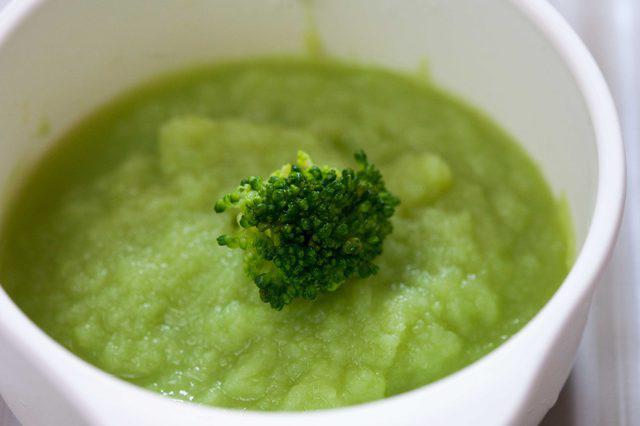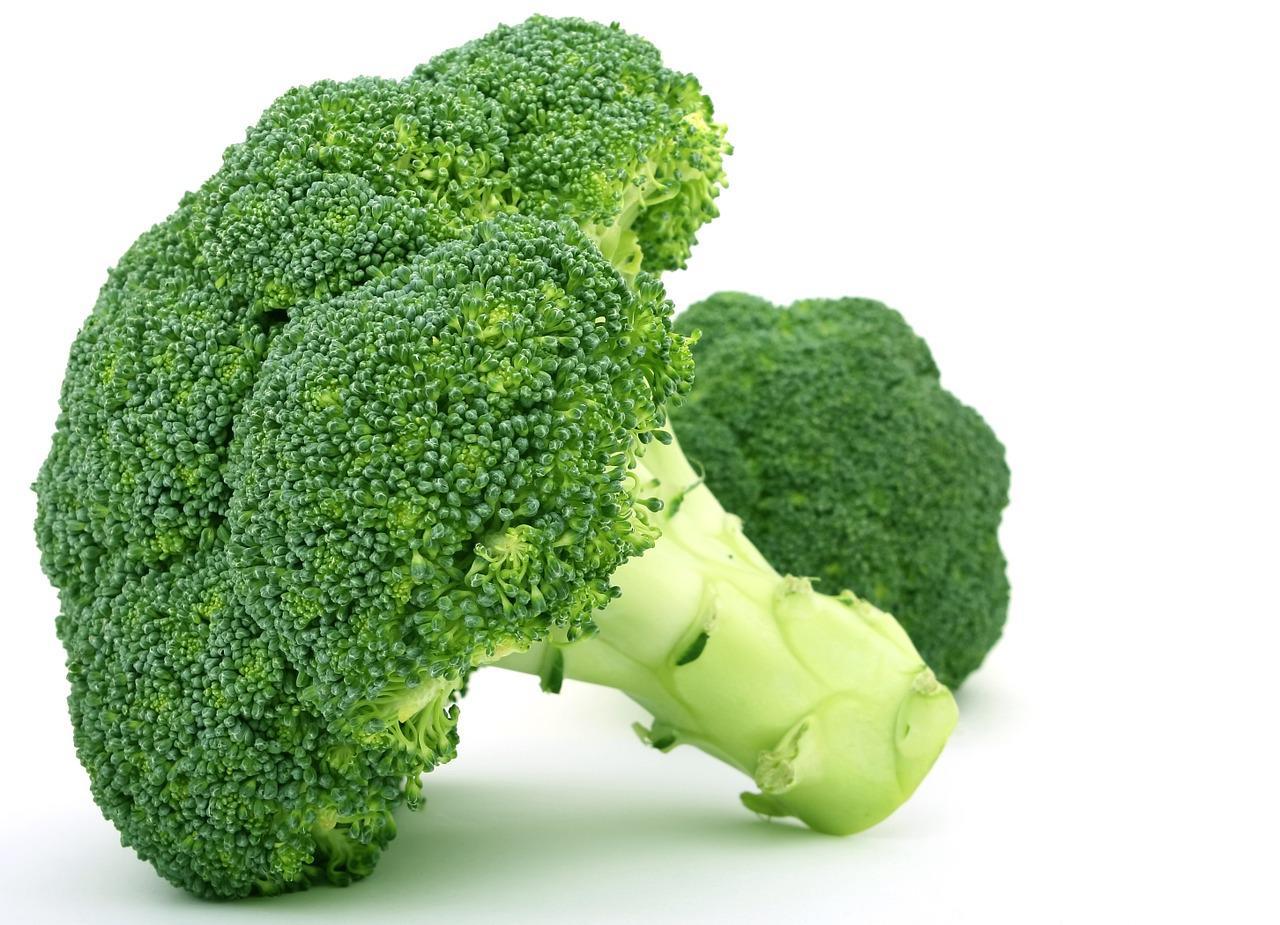The first image is the image on the left, the second image is the image on the right. Examine the images to the left and right. Is the description "An image includes a white bowl that contains multiple broccoli florets." accurate? Answer yes or no. No. The first image is the image on the left, the second image is the image on the right. Given the left and right images, does the statement "Brocolli sits in a white bowl in the image on the right." hold true? Answer yes or no. No. 